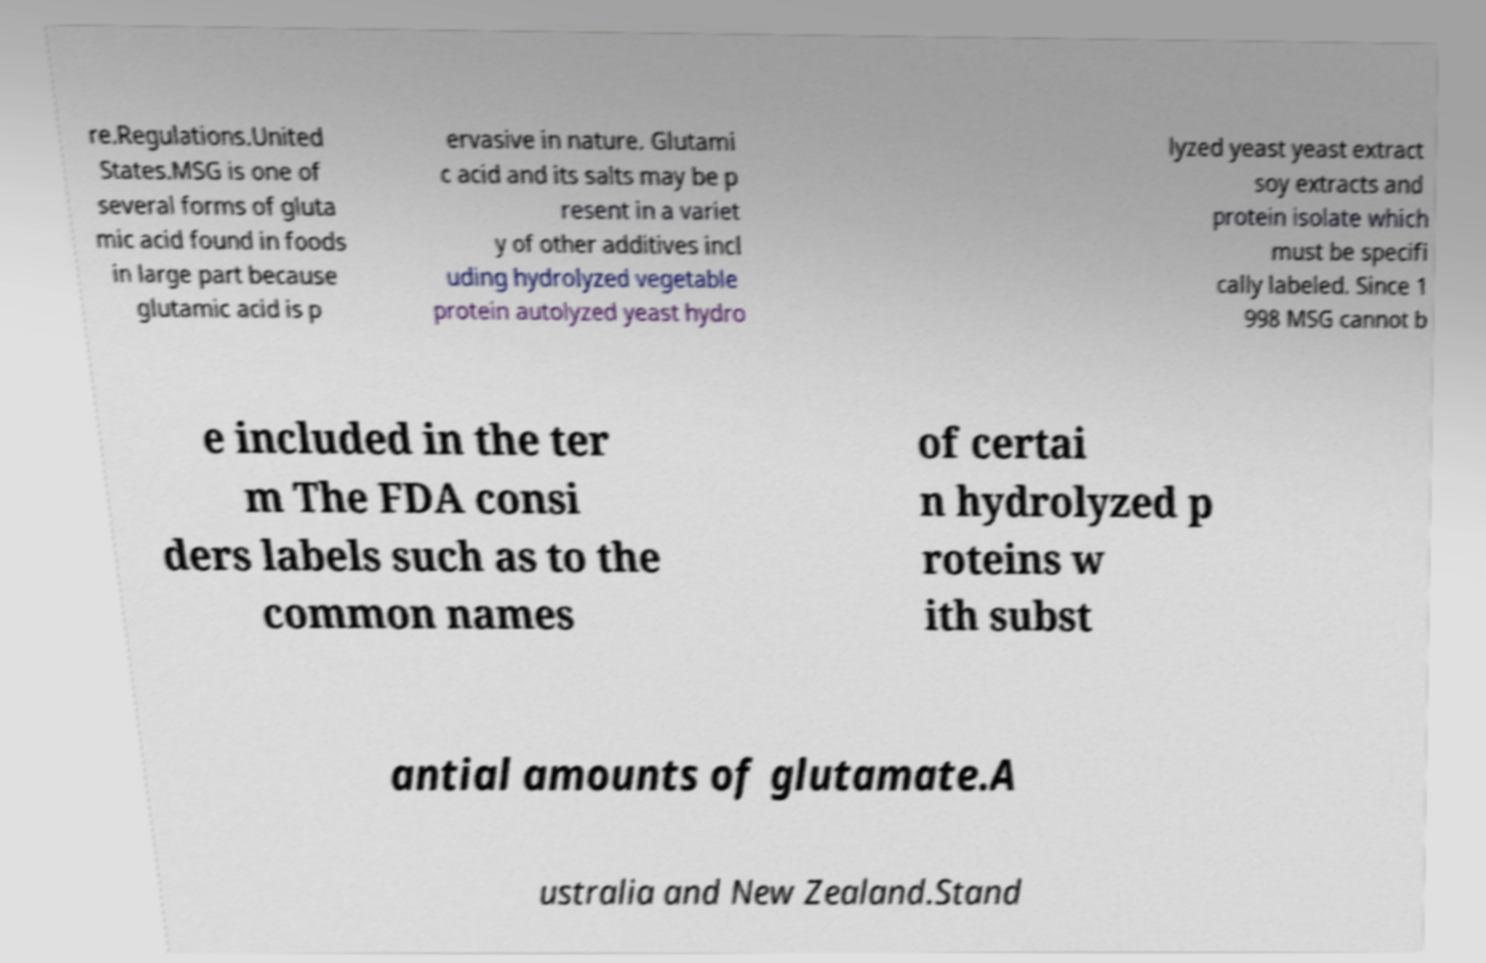Please read and relay the text visible in this image. What does it say? re.Regulations.United States.MSG is one of several forms of gluta mic acid found in foods in large part because glutamic acid is p ervasive in nature. Glutami c acid and its salts may be p resent in a variet y of other additives incl uding hydrolyzed vegetable protein autolyzed yeast hydro lyzed yeast yeast extract soy extracts and protein isolate which must be specifi cally labeled. Since 1 998 MSG cannot b e included in the ter m The FDA consi ders labels such as to the common names of certai n hydrolyzed p roteins w ith subst antial amounts of glutamate.A ustralia and New Zealand.Stand 